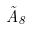<formula> <loc_0><loc_0><loc_500><loc_500>\tilde { A } _ { 8 }</formula> 